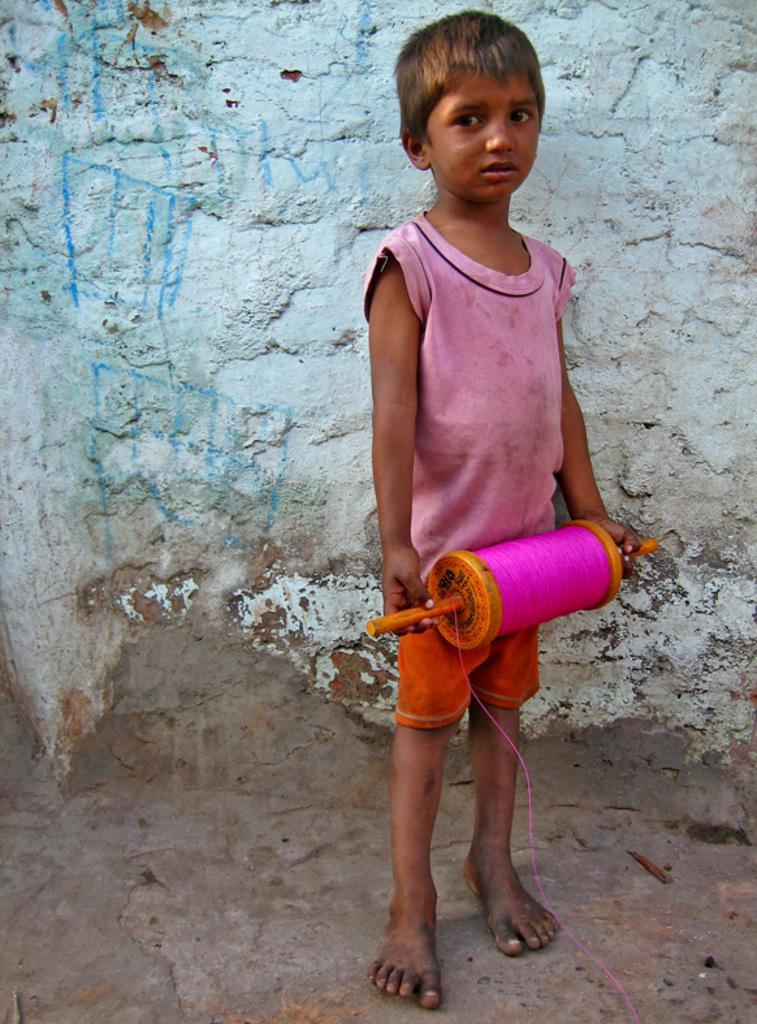Can you describe this image briefly? In this image there is a kid standing on a floor and holding and object in hands, in the background there is a wall. 